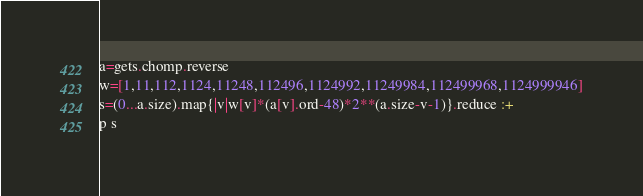Convert code to text. <code><loc_0><loc_0><loc_500><loc_500><_Ruby_>a=gets.chomp.reverse
w=[1,11,112,1124,11248,112496,1124992,11249984,112499968,1124999946]
s=(0...a.size).map{|v|w[v]*(a[v].ord-48)*2**(a.size-v-1)}.reduce :+
p s
</code> 